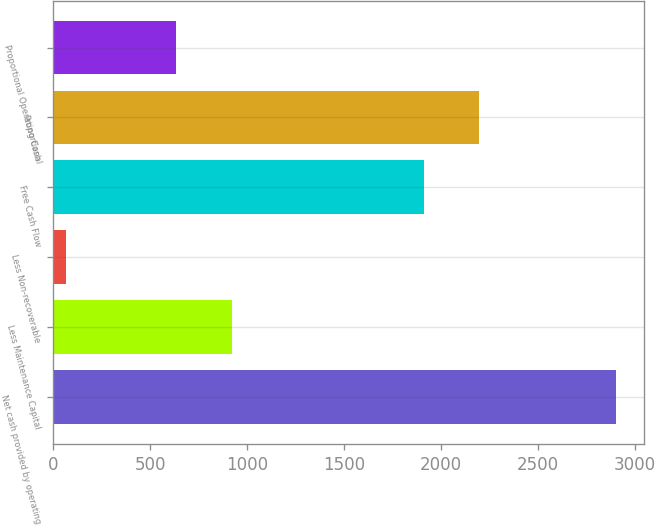Convert chart. <chart><loc_0><loc_0><loc_500><loc_500><bar_chart><fcel>Net cash provided by operating<fcel>Less Maintenance Capital<fcel>Less Non-recoverable<fcel>Free Cash Flow<fcel>Proportional<fcel>Proportional Operating Cash<nl><fcel>2901<fcel>923<fcel>66<fcel>1912<fcel>2195.5<fcel>634<nl></chart> 